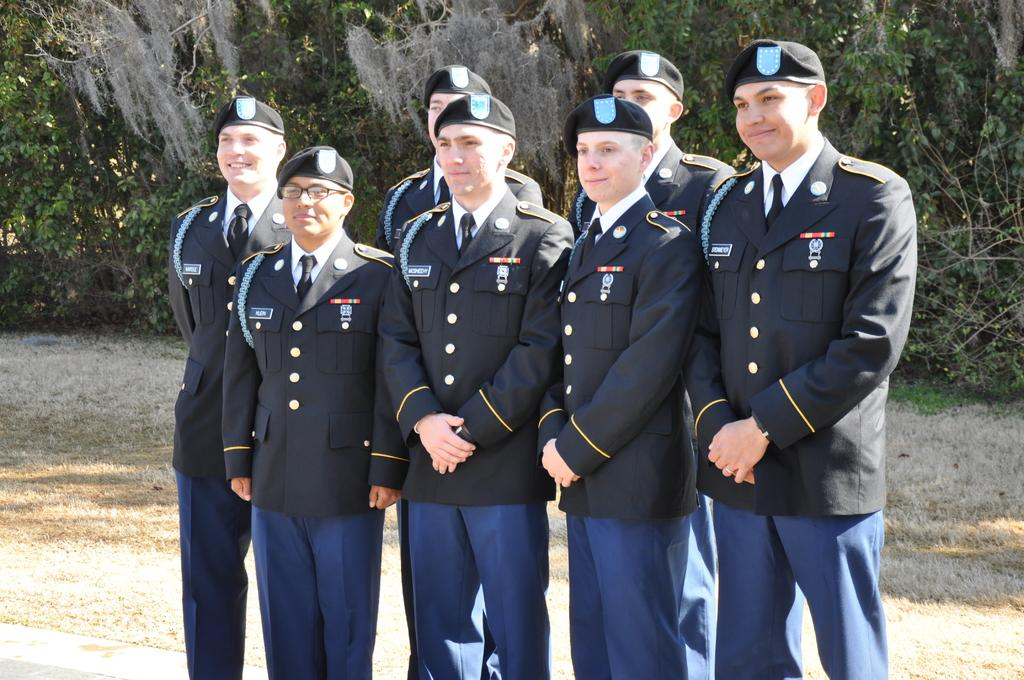Who is present in the image? There are people in the image. What are the people doing in the image? The people are standing and taking pictures. What can be seen in the background of the image? There are trees visible in the background of the image. What type of police vehicle can be seen in the image? There is no police vehicle present in the image. How does the heat affect the people in the image? The image does not provide any information about the temperature or heat, so it cannot be determined how it affects the people. 